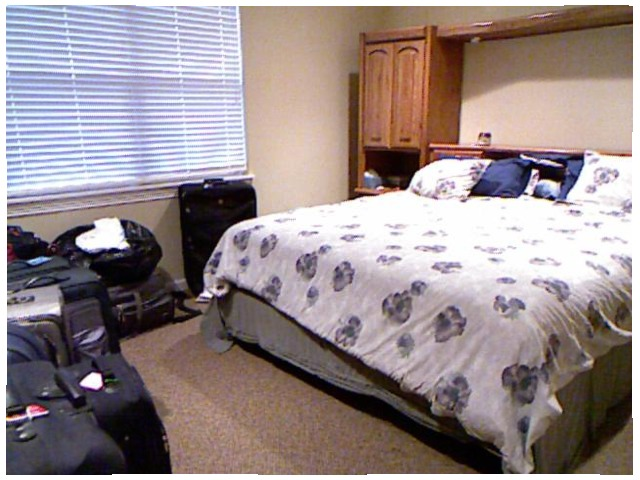<image>
Can you confirm if the bed is under the pillow? Yes. The bed is positioned underneath the pillow, with the pillow above it in the vertical space. Is the bag on the floor? Yes. Looking at the image, I can see the bag is positioned on top of the floor, with the floor providing support. 